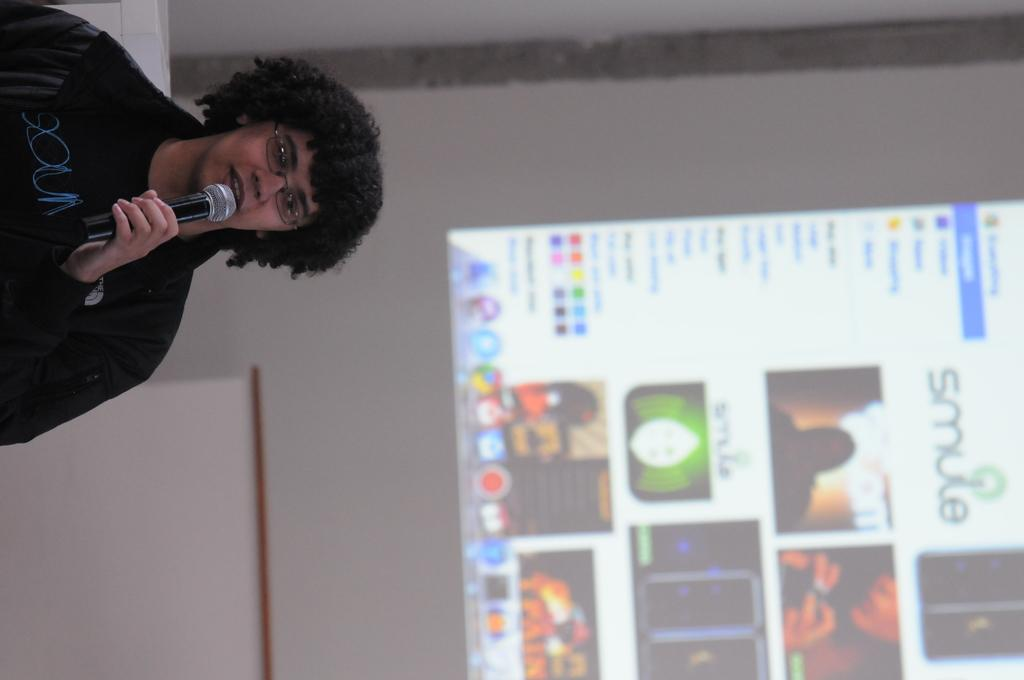What is the person in the image doing? The person is standing and talking in the image. What object is the person holding? The person is holding a microphone. What can be seen in the background of the image? There is a screen visible in the background of the image. How many cattle are present in the image? There are no cattle present in the image. What type of spiders can be seen crawling on the person's hand in the image? There are no spiders visible in the image, and the person's hand is not shown. 